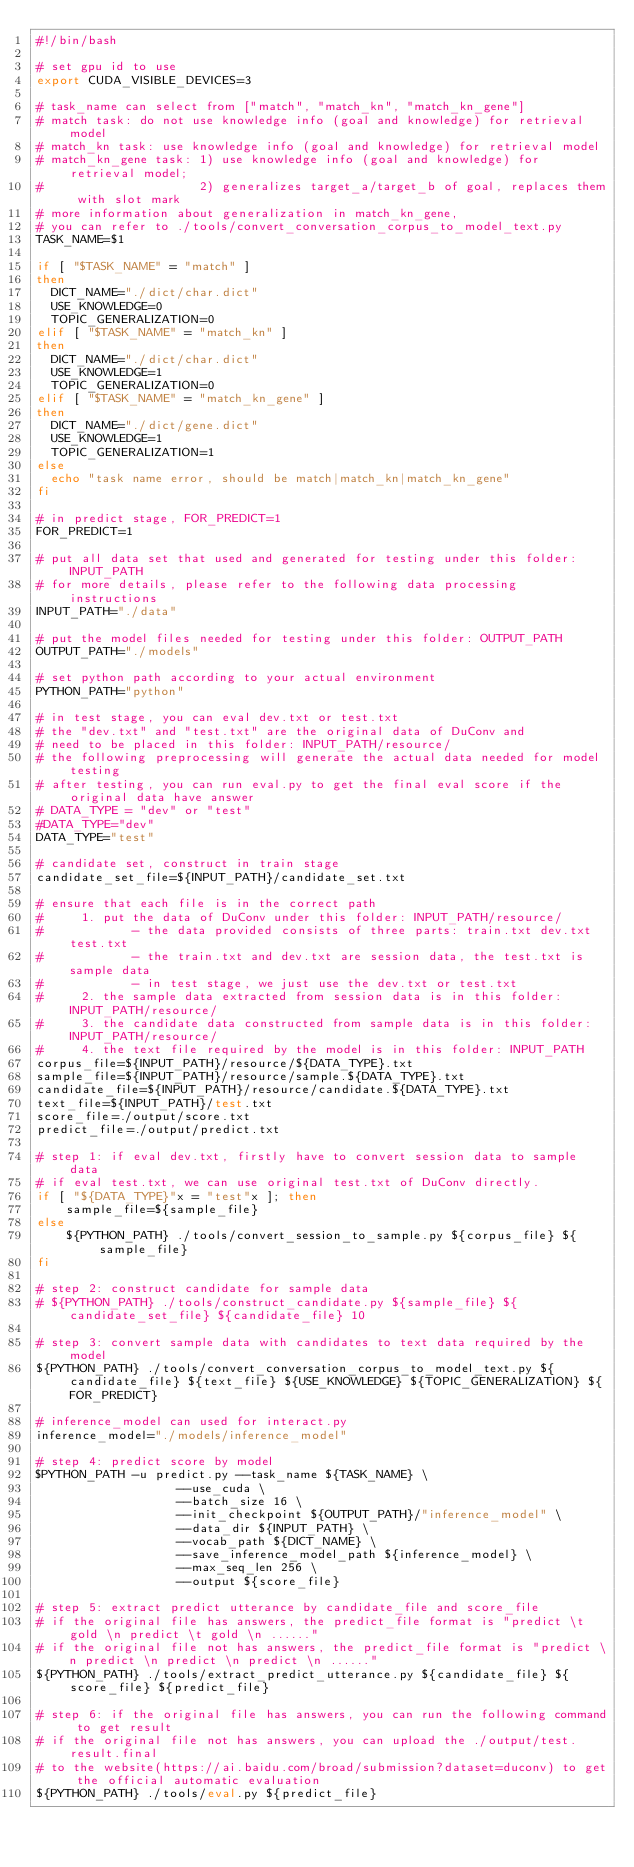<code> <loc_0><loc_0><loc_500><loc_500><_Bash_>#!/bin/bash

# set gpu id to use
export CUDA_VISIBLE_DEVICES=3

# task_name can select from ["match", "match_kn", "match_kn_gene"]
# match task: do not use knowledge info (goal and knowledge) for retrieval model
# match_kn task: use knowledge info (goal and knowledge) for retrieval model
# match_kn_gene task: 1) use knowledge info (goal and knowledge) for retrieval model;
#                     2) generalizes target_a/target_b of goal, replaces them with slot mark
# more information about generalization in match_kn_gene,
# you can refer to ./tools/convert_conversation_corpus_to_model_text.py
TASK_NAME=$1

if [ "$TASK_NAME" = "match" ]
then
  DICT_NAME="./dict/char.dict"
  USE_KNOWLEDGE=0
  TOPIC_GENERALIZATION=0
elif [ "$TASK_NAME" = "match_kn" ]
then
  DICT_NAME="./dict/char.dict"
  USE_KNOWLEDGE=1
  TOPIC_GENERALIZATION=0
elif [ "$TASK_NAME" = "match_kn_gene" ]
then
  DICT_NAME="./dict/gene.dict"
  USE_KNOWLEDGE=1
  TOPIC_GENERALIZATION=1
else
  echo "task name error, should be match|match_kn|match_kn_gene"
fi

# in predict stage, FOR_PREDICT=1
FOR_PREDICT=1

# put all data set that used and generated for testing under this folder: INPUT_PATH
# for more details, please refer to the following data processing instructions
INPUT_PATH="./data"

# put the model files needed for testing under this folder: OUTPUT_PATH
OUTPUT_PATH="./models"

# set python path according to your actual environment
PYTHON_PATH="python"

# in test stage, you can eval dev.txt or test.txt
# the "dev.txt" and "test.txt" are the original data of DuConv and
# need to be placed in this folder: INPUT_PATH/resource/
# the following preprocessing will generate the actual data needed for model testing
# after testing, you can run eval.py to get the final eval score if the original data have answer
# DATA_TYPE = "dev" or "test"
#DATA_TYPE="dev"
DATA_TYPE="test"

# candidate set, construct in train stage
candidate_set_file=${INPUT_PATH}/candidate_set.txt

# ensure that each file is in the correct path
#     1. put the data of DuConv under this folder: INPUT_PATH/resource/
#            - the data provided consists of three parts: train.txt dev.txt test.txt
#            - the train.txt and dev.txt are session data, the test.txt is sample data
#            - in test stage, we just use the dev.txt or test.txt
#     2. the sample data extracted from session data is in this folder: INPUT_PATH/resource/
#     3. the candidate data constructed from sample data is in this folder: INPUT_PATH/resource/
#     4. the text file required by the model is in this folder: INPUT_PATH
corpus_file=${INPUT_PATH}/resource/${DATA_TYPE}.txt
sample_file=${INPUT_PATH}/resource/sample.${DATA_TYPE}.txt
candidate_file=${INPUT_PATH}/resource/candidate.${DATA_TYPE}.txt
text_file=${INPUT_PATH}/test.txt
score_file=./output/score.txt
predict_file=./output/predict.txt

# step 1: if eval dev.txt, firstly have to convert session data to sample data
# if eval test.txt, we can use original test.txt of DuConv directly.
if [ "${DATA_TYPE}"x = "test"x ]; then
    sample_file=${sample_file}
else
    ${PYTHON_PATH} ./tools/convert_session_to_sample.py ${corpus_file} ${sample_file}
fi

# step 2: construct candidate for sample data
# ${PYTHON_PATH} ./tools/construct_candidate.py ${sample_file} ${candidate_set_file} ${candidate_file} 10

# step 3: convert sample data with candidates to text data required by the model
${PYTHON_PATH} ./tools/convert_conversation_corpus_to_model_text.py ${candidate_file} ${text_file} ${USE_KNOWLEDGE} ${TOPIC_GENERALIZATION} ${FOR_PREDICT}

# inference_model can used for interact.py
inference_model="./models/inference_model"

# step 4: predict score by model
$PYTHON_PATH -u predict.py --task_name ${TASK_NAME} \
                   --use_cuda \
                   --batch_size 16 \
                   --init_checkpoint ${OUTPUT_PATH}/"inference_model" \
                   --data_dir ${INPUT_PATH} \
                   --vocab_path ${DICT_NAME} \
                   --save_inference_model_path ${inference_model} \
                   --max_seq_len 256 \
                   --output ${score_file}

# step 5: extract predict utterance by candidate_file and score_file
# if the original file has answers, the predict_file format is "predict \t gold \n predict \t gold \n ......"
# if the original file not has answers, the predict_file format is "predict \n predict \n predict \n predict \n ......"
${PYTHON_PATH} ./tools/extract_predict_utterance.py ${candidate_file} ${score_file} ${predict_file}

# step 6: if the original file has answers, you can run the following command to get result
# if the original file not has answers, you can upload the ./output/test.result.final 
# to the website(https://ai.baidu.com/broad/submission?dataset=duconv) to get the official automatic evaluation
${PYTHON_PATH} ./tools/eval.py ${predict_file}
</code> 